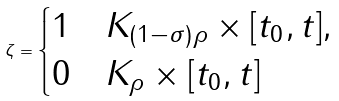<formula> <loc_0><loc_0><loc_500><loc_500>\zeta = \begin{cases} 1 & K _ { ( 1 - \sigma ) \rho } \times [ t _ { 0 } , t ] , \\ 0 & K _ { \rho } \times [ t _ { 0 } , t ] \end{cases}</formula> 